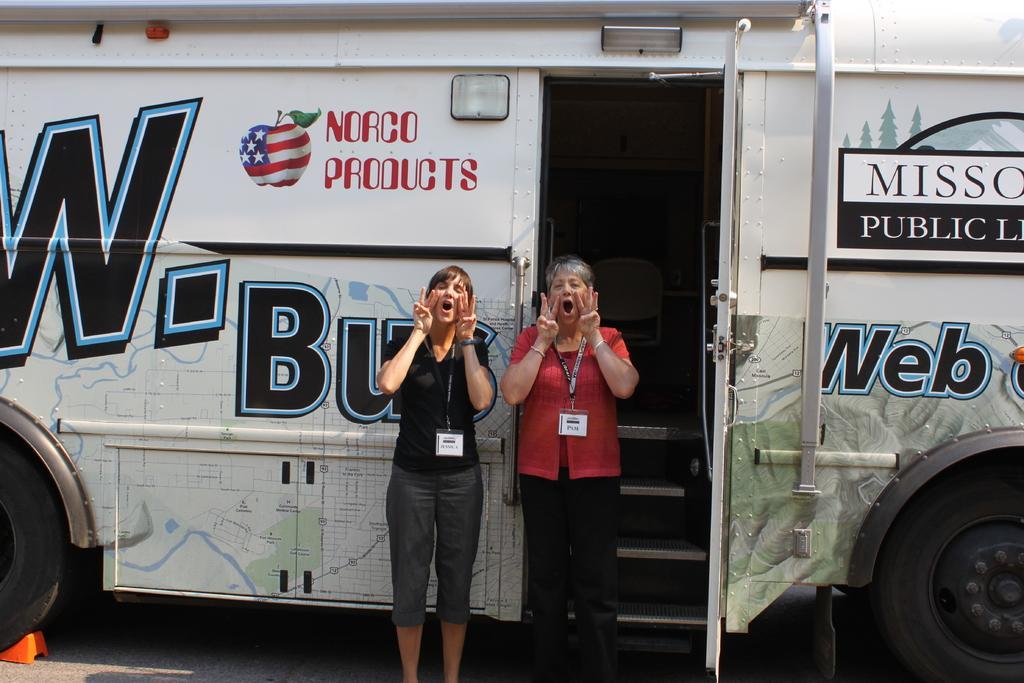In one or two sentences, can you explain what this image depicts? In this image in front there are two people shouting. Behind them there is a bus on the road. 